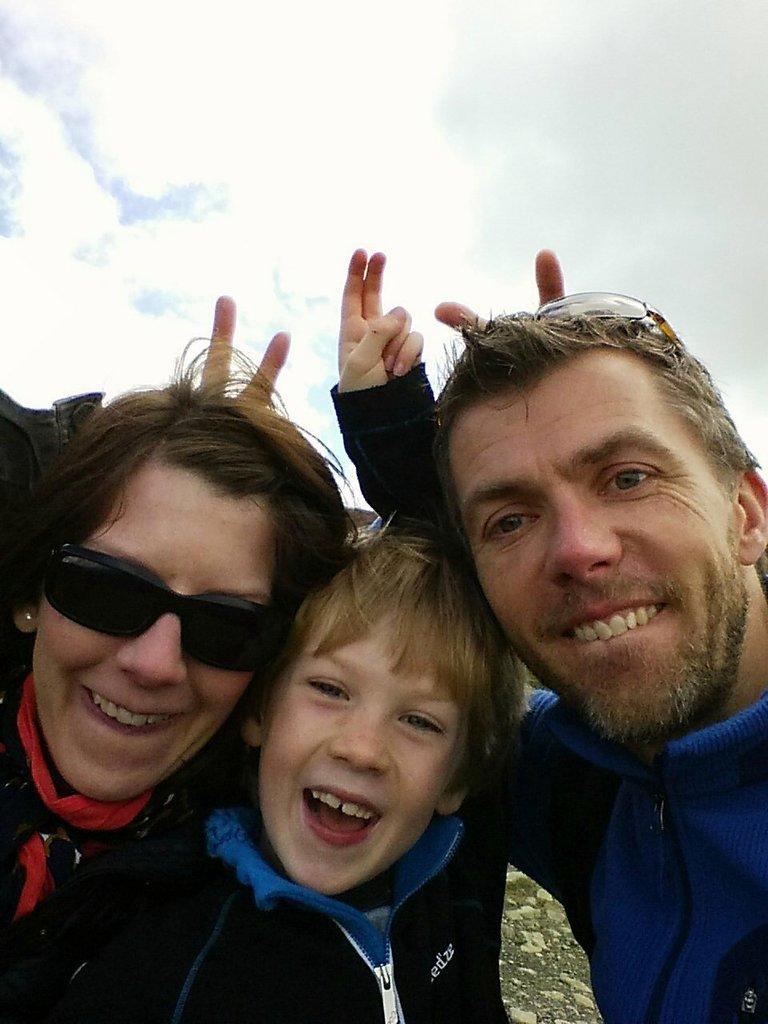Describe this image in one or two sentences. In the foreground of this image, there is a woman, man and a boy raising fingers behind the heads. In the background, there is the sky and the cloud. 